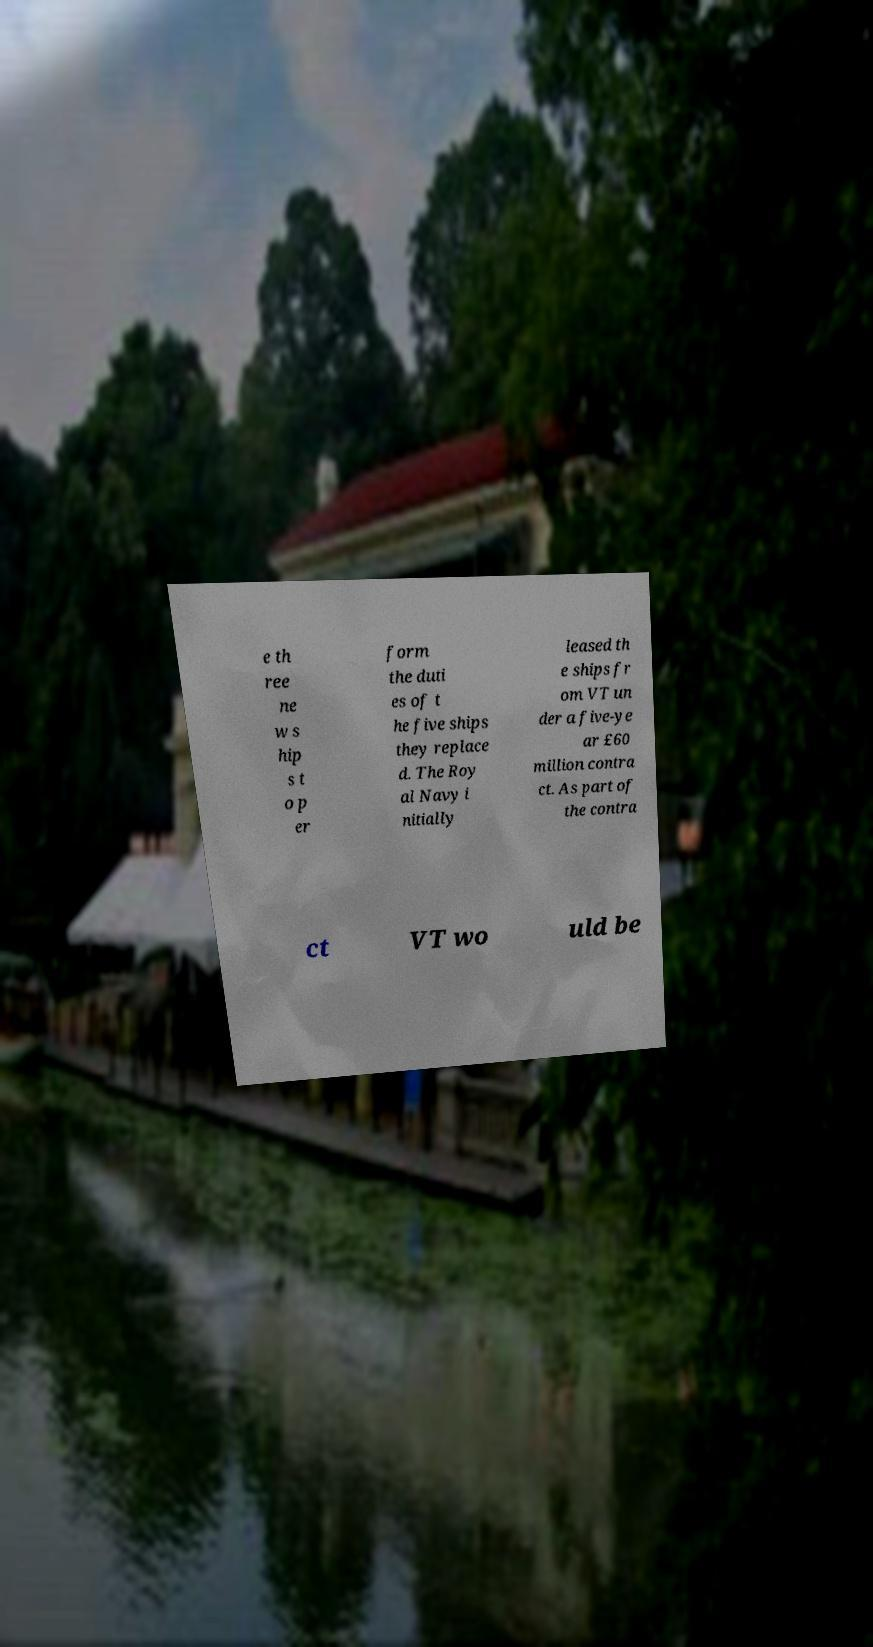Could you extract and type out the text from this image? e th ree ne w s hip s t o p er form the duti es of t he five ships they replace d. The Roy al Navy i nitially leased th e ships fr om VT un der a five-ye ar £60 million contra ct. As part of the contra ct VT wo uld be 